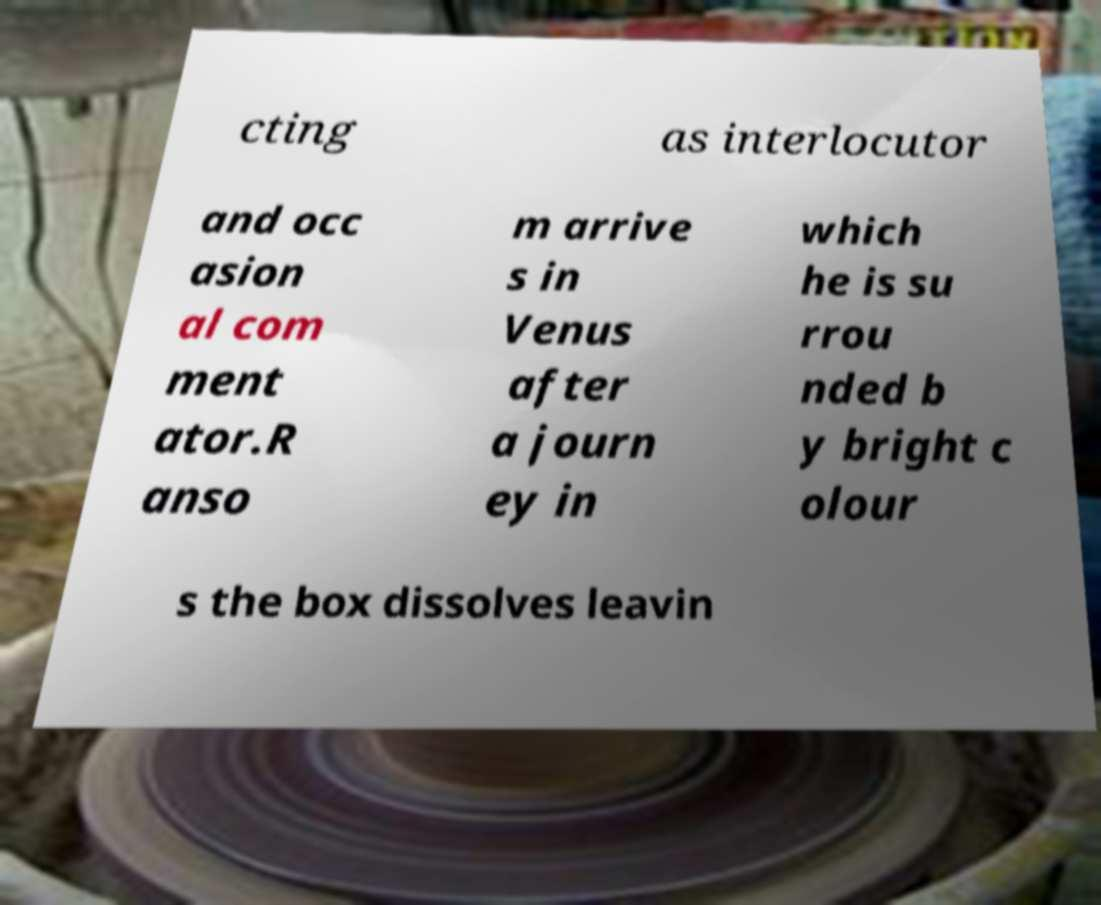Could you extract and type out the text from this image? cting as interlocutor and occ asion al com ment ator.R anso m arrive s in Venus after a journ ey in which he is su rrou nded b y bright c olour s the box dissolves leavin 